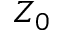<formula> <loc_0><loc_0><loc_500><loc_500>Z _ { 0 }</formula> 